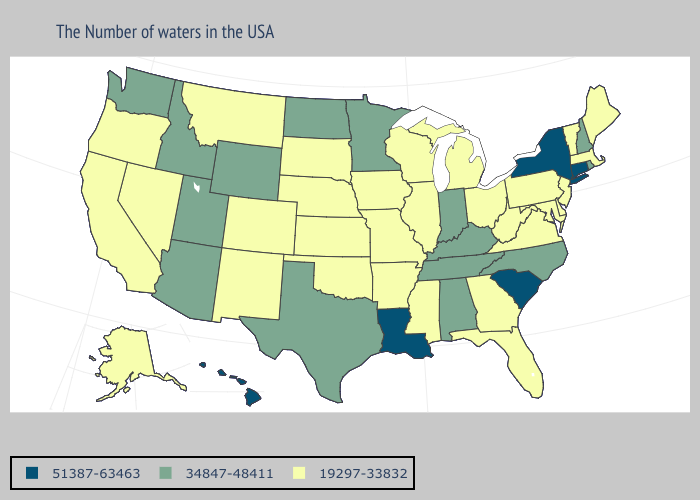Does Alabama have the same value as North Carolina?
Keep it brief. Yes. Does Oklahoma have a higher value than Tennessee?
Quick response, please. No. What is the value of Hawaii?
Short answer required. 51387-63463. Name the states that have a value in the range 34847-48411?
Be succinct. Rhode Island, New Hampshire, North Carolina, Kentucky, Indiana, Alabama, Tennessee, Minnesota, Texas, North Dakota, Wyoming, Utah, Arizona, Idaho, Washington. Does the map have missing data?
Give a very brief answer. No. What is the value of Illinois?
Keep it brief. 19297-33832. Name the states that have a value in the range 19297-33832?
Answer briefly. Maine, Massachusetts, Vermont, New Jersey, Delaware, Maryland, Pennsylvania, Virginia, West Virginia, Ohio, Florida, Georgia, Michigan, Wisconsin, Illinois, Mississippi, Missouri, Arkansas, Iowa, Kansas, Nebraska, Oklahoma, South Dakota, Colorado, New Mexico, Montana, Nevada, California, Oregon, Alaska. Among the states that border Wyoming , which have the lowest value?
Concise answer only. Nebraska, South Dakota, Colorado, Montana. What is the value of Rhode Island?
Be succinct. 34847-48411. How many symbols are there in the legend?
Short answer required. 3. What is the value of New York?
Short answer required. 51387-63463. Among the states that border Georgia , does South Carolina have the highest value?
Quick response, please. Yes. What is the value of Kentucky?
Short answer required. 34847-48411. What is the value of Nevada?
Short answer required. 19297-33832. 